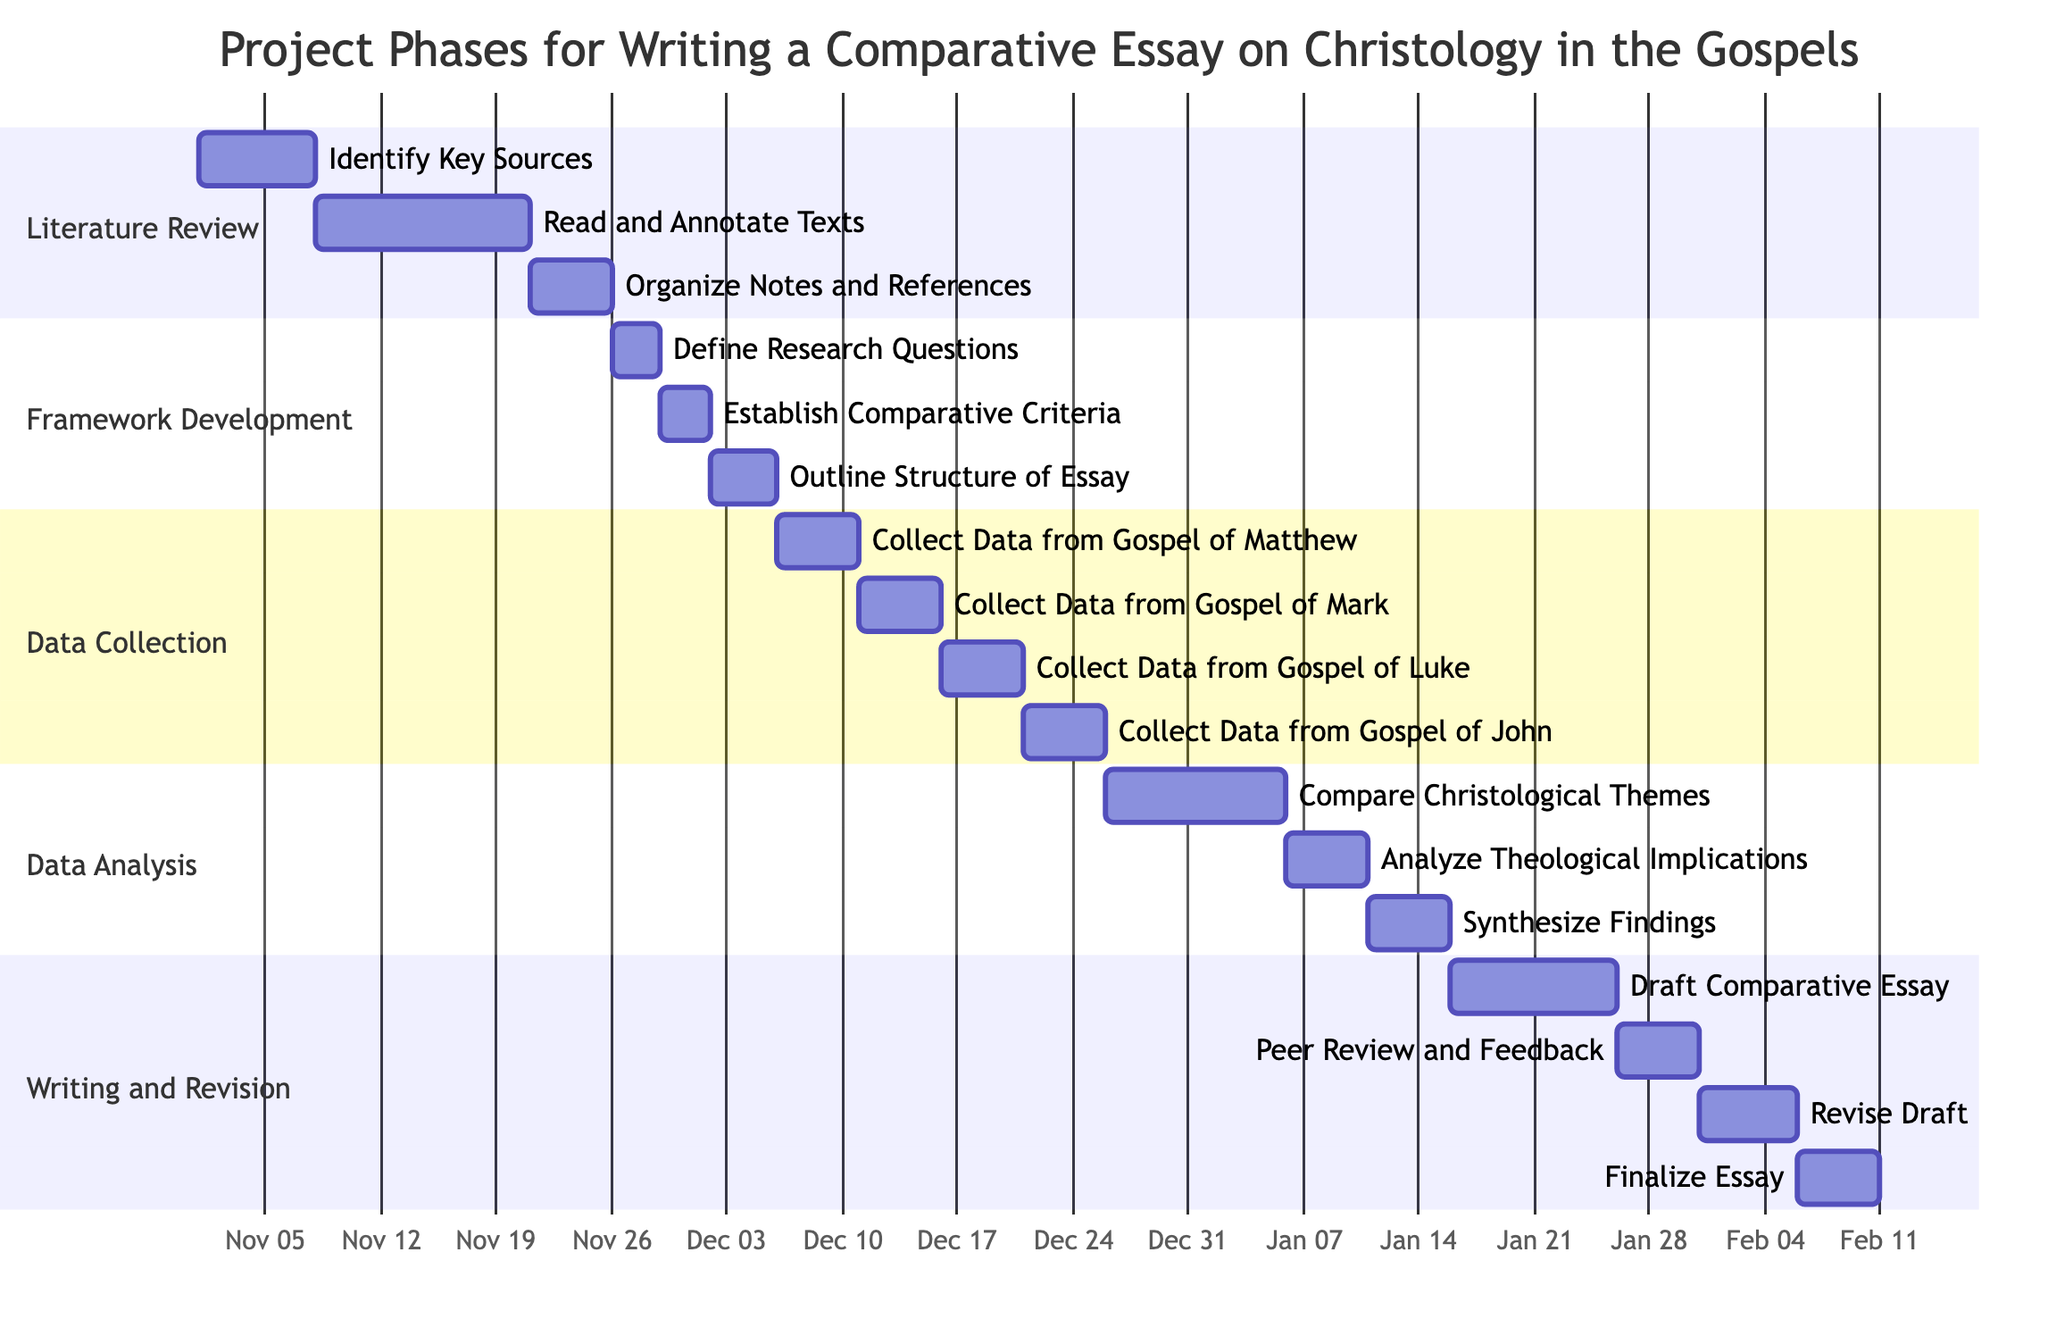What is the first task in the Literature Review phase? The first task listed under the Literature Review phase is "Identify Key Sources," which starts on November 1, 2023.
Answer: Identify Key Sources How many tasks are in the Data Collection phase? In the Data Collection phase, there are four tasks: collecting data from the Gospels of Matthew, Mark, Luke, and John.
Answer: 4 What is the end date for the "Draft Comparative Essay" task? The task "Draft Comparative Essay" ends on January 25, 2024, as indicated in the Gantt chart timeline for the Writing and Revision phase.
Answer: January 25, 2024 Which task follows "Analyze Theological Implications"? The task that follows "Analyze Theological Implications" is "Synthesize Findings," based on the order of tasks in the Data Analysis phase.
Answer: Synthesize Findings What is the duration of the "Organize Notes and References" task? "Organize Notes and References" starts on November 21, 2023, and ends on November 25, 2023, resulting in a duration of five days.
Answer: 5 days Which phase has the shortest duration for its tasks? The Framework Development phase has the shortest tasks' duration, with all tasks totaling only ten days (3+3+4 days).
Answer: Framework Development What are the start and end dates for the "Establish Comparative Criteria" task? The task "Establish Comparative Criteria" starts on November 29, 2023, and ends on December 1, 2023, as detailed in the Framework Development section.
Answer: November 29, 2023 to December 1, 2023 What is the last task before the "Finalize Essay"? The last task before the "Finalize Essay" is "Revise Draft," occurring from January 31 to February 5, 2024.
Answer: Revise Draft How many phases are included in this Gantt chart? The Gantt chart includes five distinct phases, which are Literature Review, Framework Development, Data Collection, Data Analysis, and Writing and Revision.
Answer: 5 